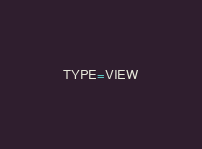<code> <loc_0><loc_0><loc_500><loc_500><_VisualBasic_>TYPE=VIEW</code> 